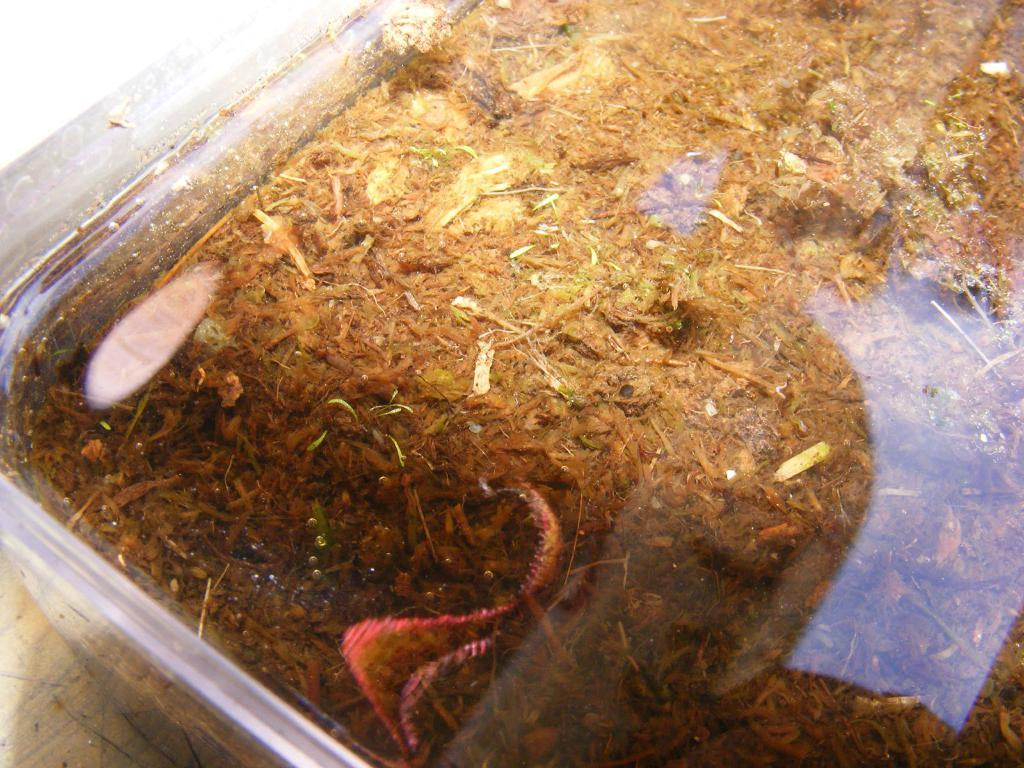What object can be seen in the image that is used for storage? There is a storage box in the image. What substance is present in the image that is commonly used as fertilizer? There is manure in the image. What type of crown is being worn by the maid in the image? There is no maid or crown present in the image. What suggestion is being made by the person in the image? There is no person making a suggestion in the image. 